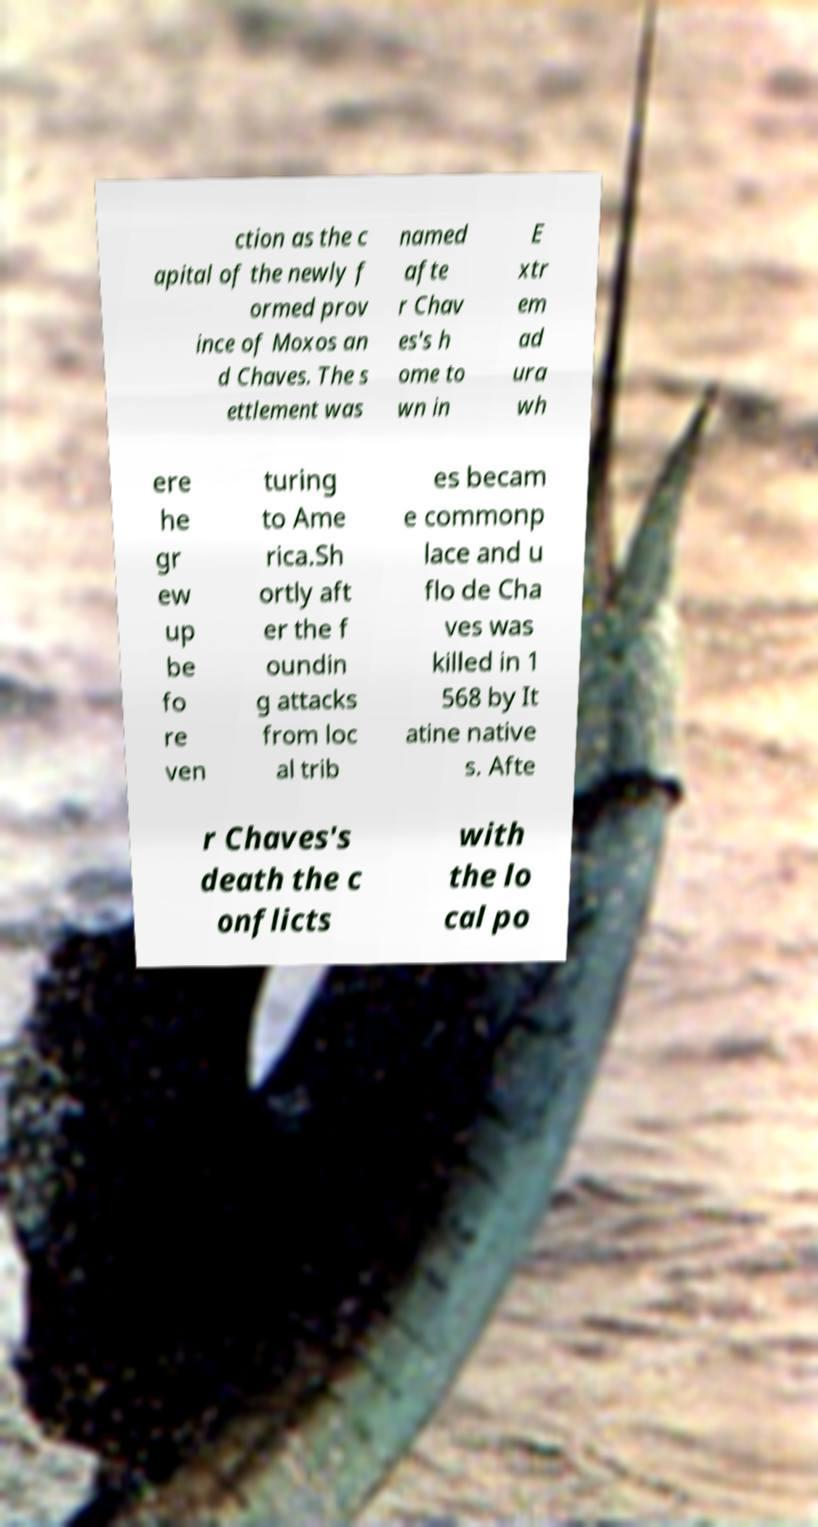Can you read and provide the text displayed in the image?This photo seems to have some interesting text. Can you extract and type it out for me? ction as the c apital of the newly f ormed prov ince of Moxos an d Chaves. The s ettlement was named afte r Chav es's h ome to wn in E xtr em ad ura wh ere he gr ew up be fo re ven turing to Ame rica.Sh ortly aft er the f oundin g attacks from loc al trib es becam e commonp lace and u flo de Cha ves was killed in 1 568 by It atine native s. Afte r Chaves's death the c onflicts with the lo cal po 